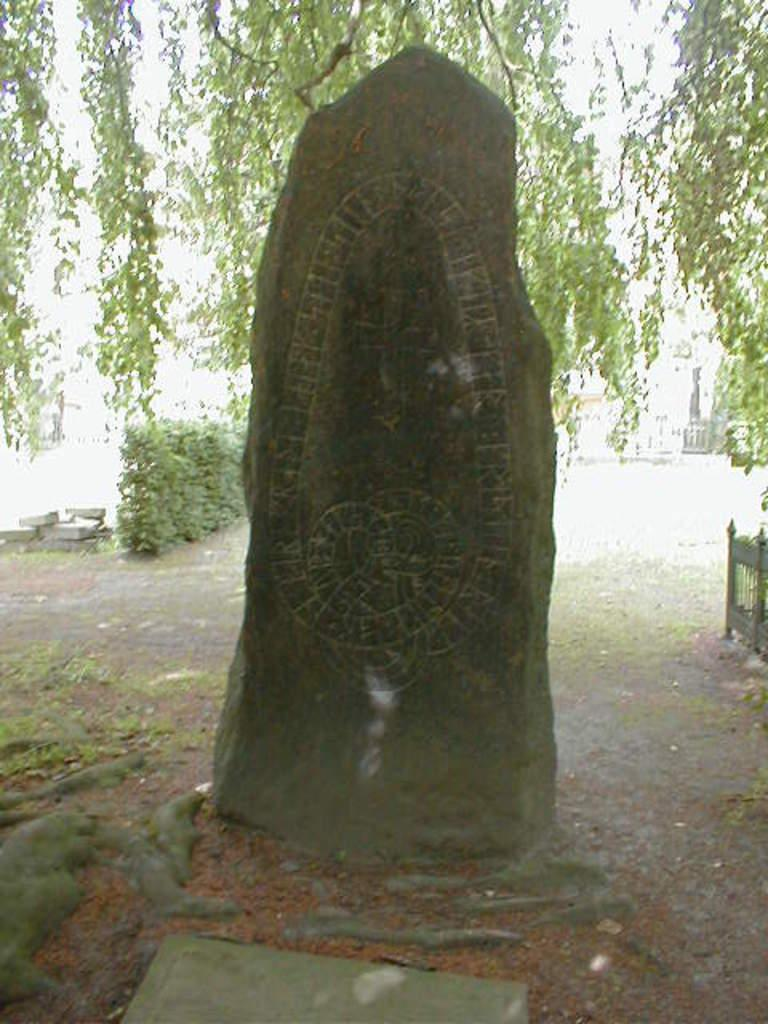What is the main subject in the center of the image? There is a stone in the center of the image. What can be seen in the background of the image? There are trees, a railing, and plants in the background of the image. What is visible at the bottom of the image? The ground is visible at the bottom of the image. Where is the church located in the image? There is no church present in the image. What type of throne can be seen in the image? There is no throne present in the image. 